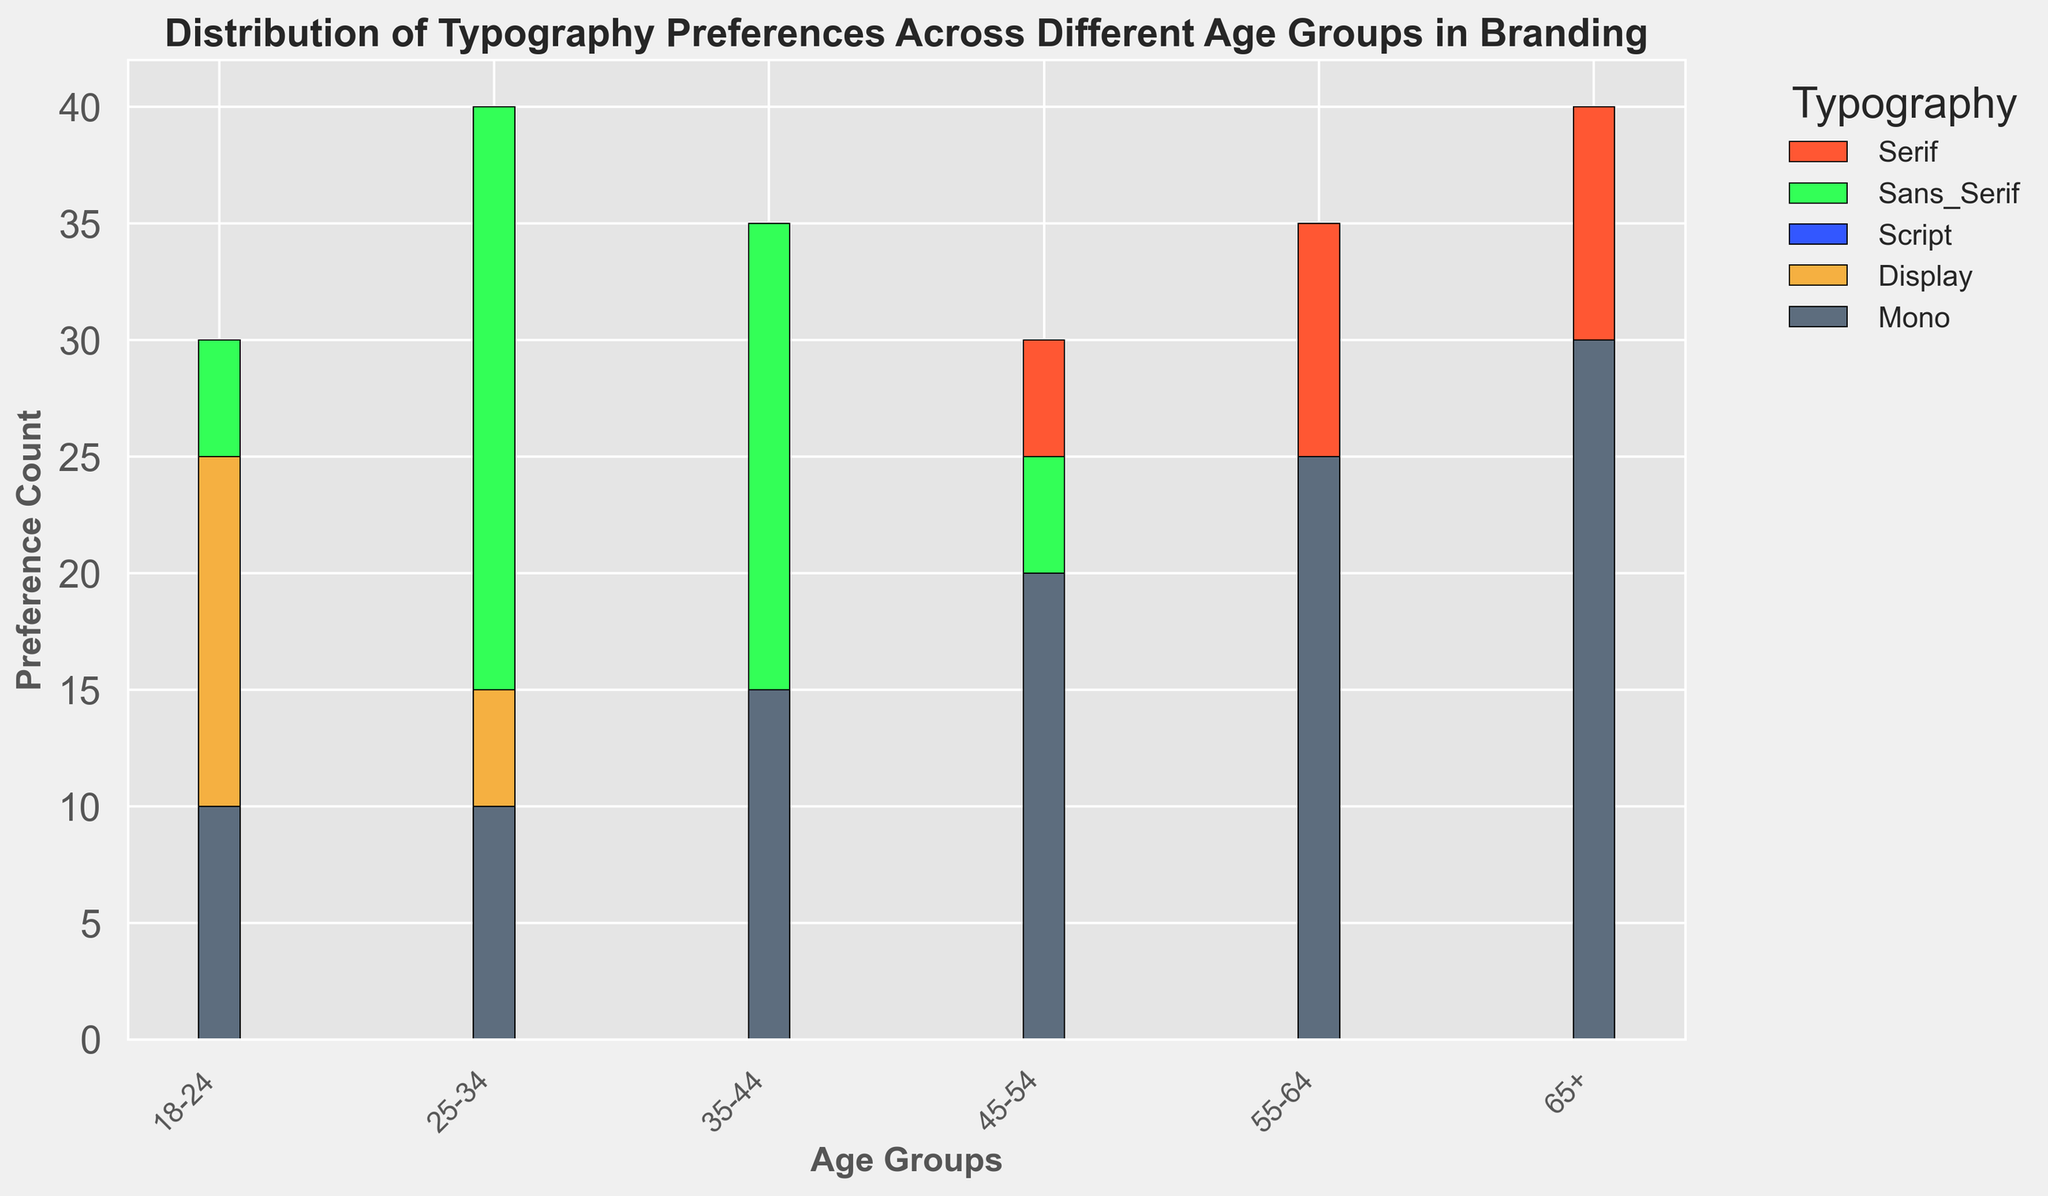What's the most preferred typography style for the age group 25-34? By observing the height of the bars corresponding to the age group 25-34, we can see that the Sans_Serif bar is the tallest
Answer: Sans_Serif What's the difference in preference for Serif typography between the age groups 18-24 and 65+? The Serif preferences for 18-24 and 65+ are 15 and 40, respectively. The difference is calculated as 40 - 15
Answer: 25 Which age group has the least preference for Script typography? By looking at the heights of the Script bars across all age groups, the 45-54, 55-64, and 65+ all have equal and minimal height of 5
Answer: 45-54, 55-64, 65+ What's the total preference count for Display typography in all age groups combined? Summing the Display preferences across all age groups: 25 + 15 + 15 + 10 + 5 + 5 = 75
Answer: 75 How do preferences for Sans_Serif typography change as age increases? Observing the heights of the Sans_Serif bars: 30 (18-24), 40 (25-34), 35 (35-44), 25 (45-54), 15 (55-64), 10 (65+), we see a decreasing trend after peaking in the 25-34 group
Answer: Decreases after 25-34 What's the ratio of preference for Mono typography between the 18-24 and 65+ age groups? Mono preferences for 18-24 and 65+ are 10 and 30, respectively. The ratio is 10/30, which simplifies to 1:3
Answer: 1:3 Which typography style has the most consistent preference (least variation) across all age groups? By comparing the height variation of each bar category, the Script typography appears to consistently show minor changes ranging from 5 to 20
Answer: Script Among all typographies, which has the highest number of preferences in a single age group? By looking for the highest single bar across all categories, the Serif typography for the 65+ group has the highest count at 40
Answer: Serif for 65+ What’s the percentage preference of Mono typography for the age group 55-64 out of its total population preferences? Mono preferences for 55-64 is 25. Total Mono preferences are: 10+10+15+20+25+30=110. The percentage is (25/110) * 100
Answer: 22.73% How does Serif typography preference change from the youngest age group to the oldest? Observing Serif bar heights from 18-24 to 65+: 15, 20, 25, 30, 35, 40. We see a consistent increase
Answer: Increases 